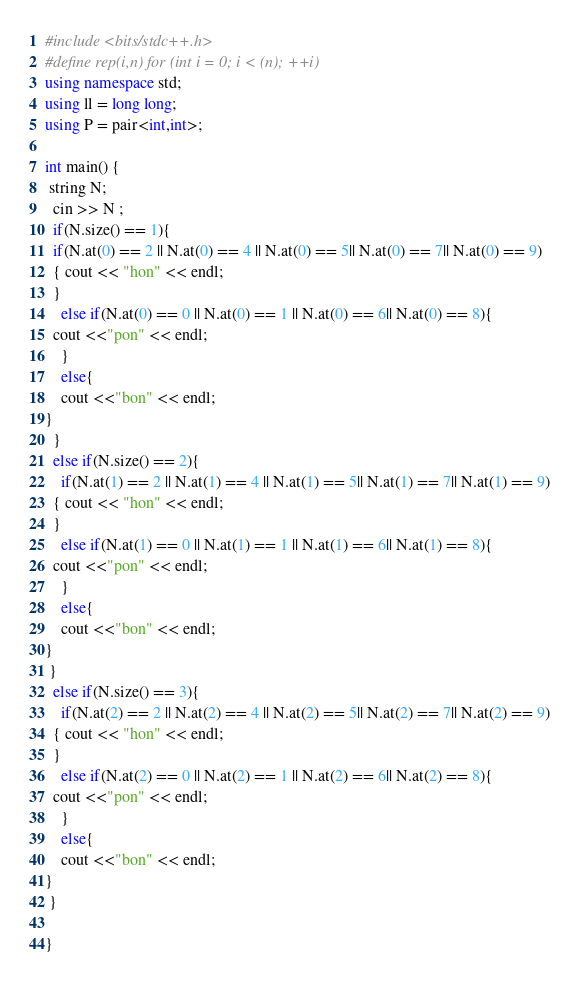Convert code to text. <code><loc_0><loc_0><loc_500><loc_500><_C++_>#include <bits/stdc++.h>
#define rep(i,n) for (int i = 0; i < (n); ++i)
using namespace std;
using ll = long long;
using P = pair<int,int>;

int main() {
 string N;
  cin >> N ;
  if(N.size() == 1){  
  if(N.at(0) == 2 || N.at(0) == 4 || N.at(0) == 5|| N.at(0) == 7|| N.at(0) == 9)
  { cout << "hon" << endl;
  }
    else if(N.at(0) == 0 || N.at(0) == 1 || N.at(0) == 6|| N.at(0) == 8){
  cout <<"pon" << endl;
    }
    else{
    cout <<"bon" << endl;
}
  }
  else if(N.size() == 2){
    if(N.at(1) == 2 || N.at(1) == 4 || N.at(1) == 5|| N.at(1) == 7|| N.at(1) == 9)
  { cout << "hon" << endl;
  }
    else if(N.at(1) == 0 || N.at(1) == 1 || N.at(1) == 6|| N.at(1) == 8){
  cout <<"pon" << endl;
    }
    else{
    cout <<"bon" << endl;
}
 }
  else if(N.size() == 3){
    if(N.at(2) == 2 || N.at(2) == 4 || N.at(2) == 5|| N.at(2) == 7|| N.at(2) == 9)
  { cout << "hon" << endl;
  }
    else if(N.at(2) == 0 || N.at(2) == 1 || N.at(2) == 6|| N.at(2) == 8){
  cout <<"pon" << endl;
    }
    else{
    cout <<"bon" << endl;
}
 }

}
</code> 